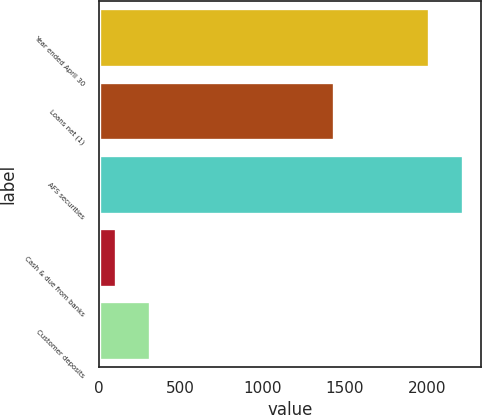<chart> <loc_0><loc_0><loc_500><loc_500><bar_chart><fcel>Year ended April 30<fcel>Loans net (1)<fcel>AFS securities<fcel>Cash & due from banks<fcel>Customer deposits<nl><fcel>2013<fcel>1432<fcel>2218.8<fcel>108<fcel>313.8<nl></chart> 